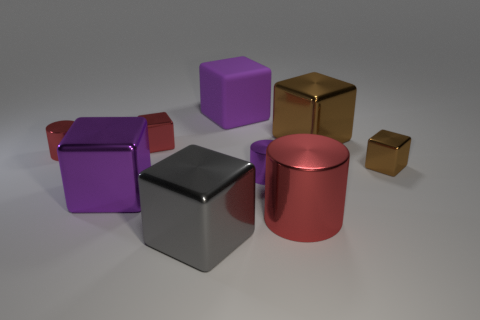What number of other objects are the same shape as the large brown metallic thing?
Your answer should be compact. 5. Is the number of small metallic objects in front of the tiny purple metallic object greater than the number of tiny cylinders that are right of the big brown metallic cube?
Provide a succinct answer. No. There is a red cylinder that is to the right of the large purple metal object; is its size the same as the red metallic cylinder behind the big red shiny object?
Your answer should be very brief. No. The rubber object is what shape?
Your answer should be very brief. Cube. The metallic cube that is the same color as the matte object is what size?
Your response must be concise. Large. What is the color of the other small cube that is made of the same material as the small brown block?
Offer a terse response. Red. Is the large brown block made of the same material as the red cylinder that is to the right of the purple matte block?
Provide a short and direct response. Yes. What is the color of the large matte object?
Provide a short and direct response. Purple. There is a purple cube that is the same material as the red cube; what size is it?
Ensure brevity in your answer.  Large. What number of small red cylinders are on the right side of the small shiny cylinder that is left of the big gray cube to the left of the tiny purple metal cylinder?
Keep it short and to the point. 0. 